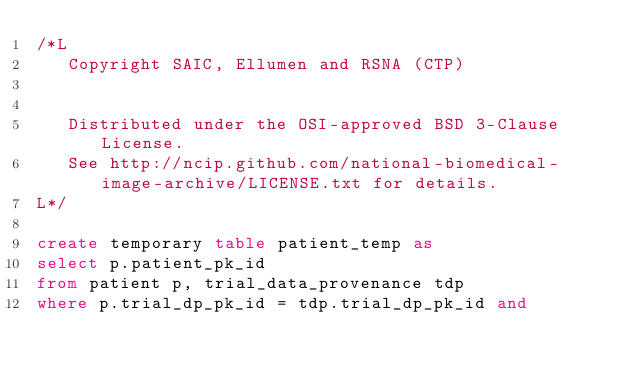Convert code to text. <code><loc_0><loc_0><loc_500><loc_500><_SQL_>/*L
   Copyright SAIC, Ellumen and RSNA (CTP)


   Distributed under the OSI-approved BSD 3-Clause License.
   See http://ncip.github.com/national-biomedical-image-archive/LICENSE.txt for details.
L*/

create temporary table patient_temp as 
select p.patient_pk_id
from patient p, trial_data_provenance tdp
where p.trial_dp_pk_id = tdp.trial_dp_pk_id and</code> 